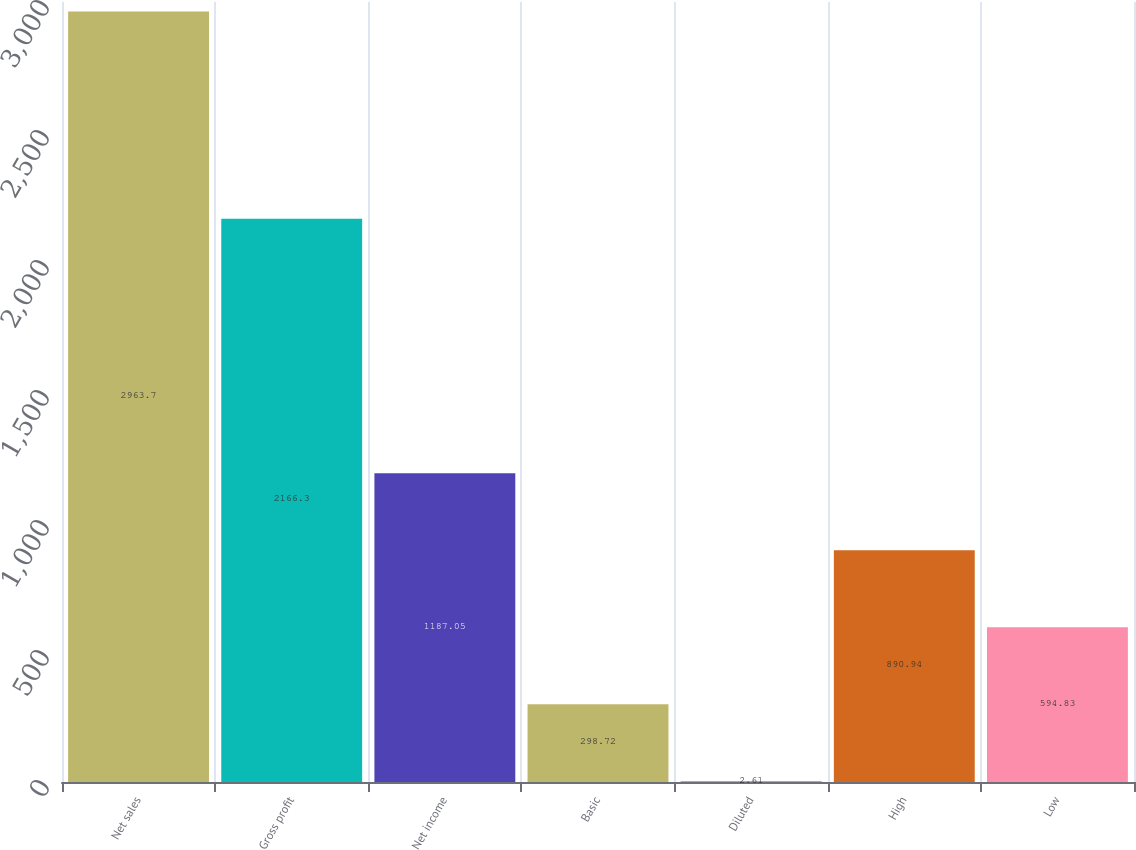Convert chart to OTSL. <chart><loc_0><loc_0><loc_500><loc_500><bar_chart><fcel>Net sales<fcel>Gross profit<fcel>Net income<fcel>Basic<fcel>Diluted<fcel>High<fcel>Low<nl><fcel>2963.7<fcel>2166.3<fcel>1187.05<fcel>298.72<fcel>2.61<fcel>890.94<fcel>594.83<nl></chart> 